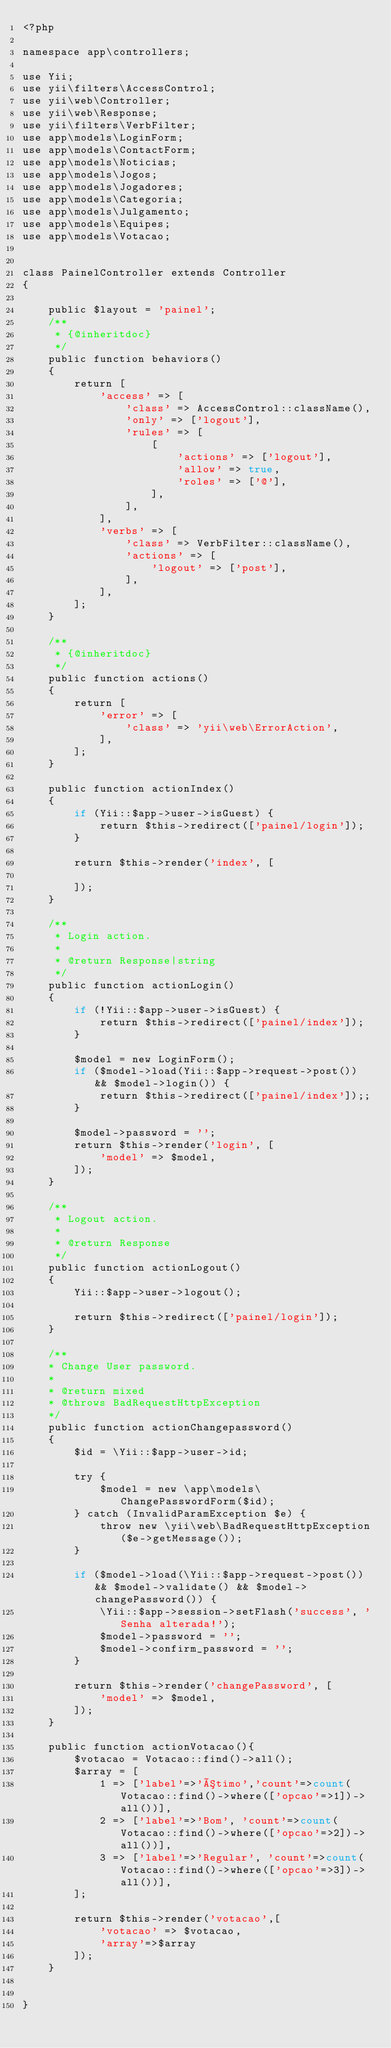<code> <loc_0><loc_0><loc_500><loc_500><_PHP_><?php

namespace app\controllers;

use Yii;
use yii\filters\AccessControl;
use yii\web\Controller;
use yii\web\Response;
use yii\filters\VerbFilter;
use app\models\LoginForm;
use app\models\ContactForm;
use app\models\Noticias;
use app\models\Jogos;
use app\models\Jogadores;
use app\models\Categoria;
use app\models\Julgamento;
use app\models\Equipes;
use app\models\Votacao;


class PainelController extends Controller
{

    public $layout = 'painel';
    /**
     * {@inheritdoc}
     */
    public function behaviors()
    {
        return [
            'access' => [
                'class' => AccessControl::className(),
                'only' => ['logout'],
                'rules' => [
                    [
                        'actions' => ['logout'],
                        'allow' => true,
                        'roles' => ['@'],
                    ],
                ],
            ],
            'verbs' => [
                'class' => VerbFilter::className(),
                'actions' => [
                    'logout' => ['post'],
                ],
            ],
        ];
    }

    /**
     * {@inheritdoc}
     */
    public function actions()
    {
        return [
            'error' => [
                'class' => 'yii\web\ErrorAction',
            ],
        ];
    }

    public function actionIndex()
    {
        if (Yii::$app->user->isGuest) {
            return $this->redirect(['painel/login']);
        }

        return $this->render('index', [

        ]);
    }

    /**
     * Login action.
     *
     * @return Response|string
     */
    public function actionLogin()
    {
        if (!Yii::$app->user->isGuest) {
            return $this->redirect(['painel/index']);
        }

        $model = new LoginForm();
        if ($model->load(Yii::$app->request->post()) && $model->login()) {
            return $this->redirect(['painel/index']);;
        }

        $model->password = '';
        return $this->render('login', [
            'model' => $model,
        ]);
    }

    /**
     * Logout action.
     *
     * @return Response
     */
    public function actionLogout()
    {
        Yii::$app->user->logout();

        return $this->redirect(['painel/login']);
    }

    /**
    * Change User password.
    *
    * @return mixed
    * @throws BadRequestHttpException
    */
    public function actionChangepassword()
    {
        $id = \Yii::$app->user->id;
    
        try {
            $model = new \app\models\ChangePasswordForm($id);
        } catch (InvalidParamException $e) {
            throw new \yii\web\BadRequestHttpException($e->getMessage());
        }
    
        if ($model->load(\Yii::$app->request->post()) && $model->validate() && $model->changePassword()) {
            \Yii::$app->session->setFlash('success', 'Senha alterada!');
            $model->password = '';
            $model->confirm_password = '';
        }
    
        return $this->render('changePassword', [
            'model' => $model,
        ]);
    }

    public function actionVotacao(){
        $votacao = Votacao::find()->all();
        $array = [
            1 => ['label'=>'Ótimo','count'=>count(Votacao::find()->where(['opcao'=>1])->all())],
            2 => ['label'=>'Bom', 'count'=>count(Votacao::find()->where(['opcao'=>2])->all())],
            3 => ['label'=>'Regular', 'count'=>count(Votacao::find()->where(['opcao'=>3])->all())],
        ];

        return $this->render('votacao',[
            'votacao' => $votacao,
            'array'=>$array
        ]);
    }


}
</code> 